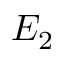Convert formula to latex. <formula><loc_0><loc_0><loc_500><loc_500>E _ { 2 }</formula> 